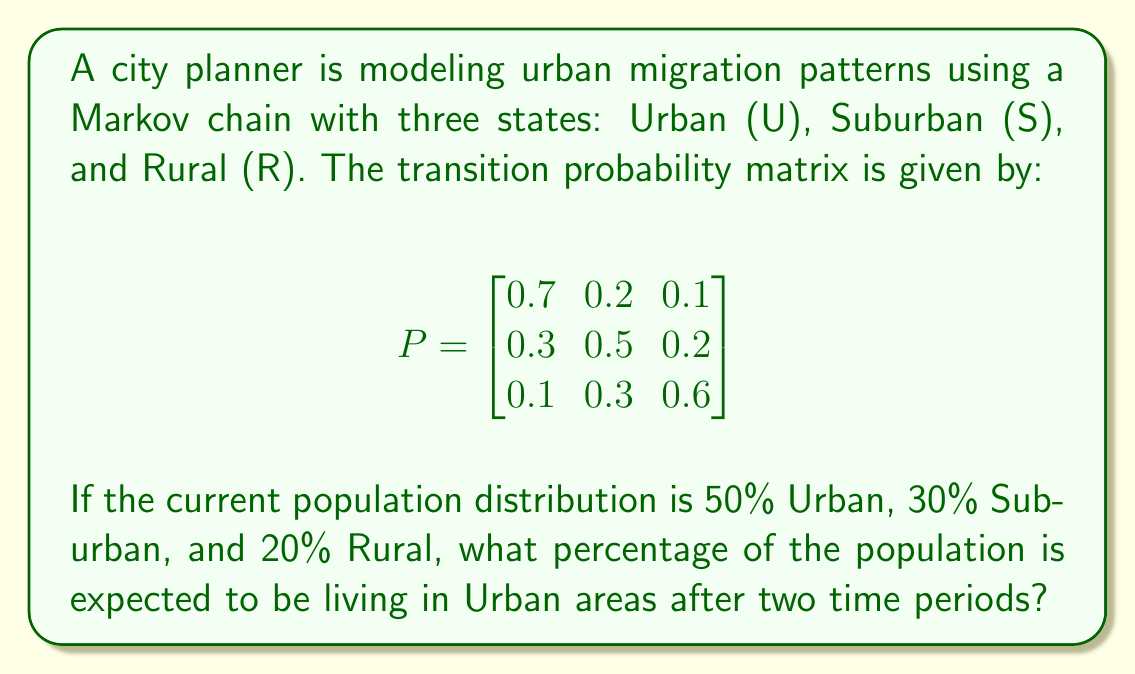Solve this math problem. To solve this problem, we'll use the Markov chain transition probability matrix and the given initial population distribution. Let's approach this step-by-step:

1. First, let's represent the initial population distribution as a row vector:
   $$\pi_0 = [0.5 \quad 0.3 \quad 0.2]$$

2. To find the distribution after two time periods, we need to multiply this initial vector by the transition matrix twice:
   $$\pi_2 = \pi_0 \cdot P^2$$

3. Let's calculate $P^2$:
   $$P^2 = P \cdot P = \begin{bmatrix}
   0.7 & 0.2 & 0.1 \\
   0.3 & 0.5 & 0.2 \\
   0.1 & 0.3 & 0.6
   \end{bmatrix} \cdot \begin{bmatrix}
   0.7 & 0.2 & 0.1 \\
   0.3 & 0.5 & 0.2 \\
   0.1 & 0.3 & 0.6
   \end{bmatrix}$$

4. Performing the matrix multiplication:
   $$P^2 = \begin{bmatrix}
   0.58 & 0.26 & 0.16 \\
   0.43 & 0.37 & 0.20 \\
   0.22 & 0.36 & 0.42
   \end{bmatrix}$$

5. Now, we multiply $\pi_0$ by $P^2$:
   $$\pi_2 = [0.5 \quad 0.3 \quad 0.2] \cdot \begin{bmatrix}
   0.58 & 0.26 & 0.16 \\
   0.43 & 0.37 & 0.20 \\
   0.22 & 0.36 & 0.42
   \end{bmatrix}$$

6. Performing this multiplication:
   $$\pi_2 = [0.5(0.58) + 0.3(0.43) + 0.2(0.22) \quad \cdots \quad \cdots]$$
   $$\pi_2 = [0.29 + 0.129 + 0.044 \quad \cdots \quad \cdots]$$
   $$\pi_2 = [0.463 \quad \cdots \quad \cdots]$$

7. We're only interested in the Urban percentage, which is the first element of $\pi_2$.

8. Converting to a percentage: $0.463 \times 100\% = 46.3\%$

Therefore, after two time periods, 46.3% of the population is expected to be living in Urban areas.
Answer: 46.3% 